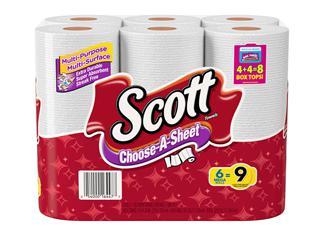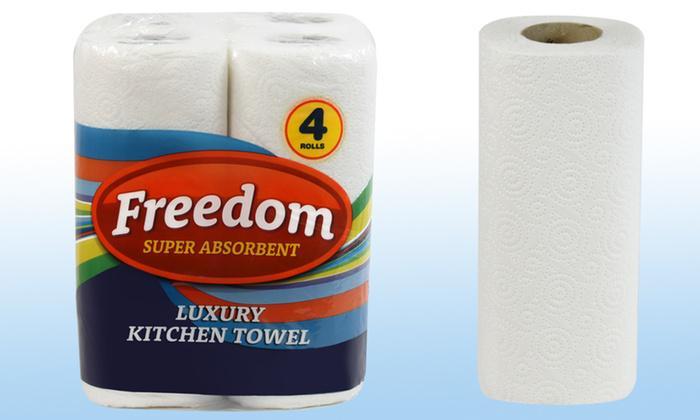The first image is the image on the left, the second image is the image on the right. Given the left and right images, does the statement "Each image shows only a sealed package of paper towels and no package contains more than three rolls." hold true? Answer yes or no. No. The first image is the image on the left, the second image is the image on the right. Assess this claim about the two images: "An image includes some amount of paper towel that is not in its wrapped package.". Correct or not? Answer yes or no. Yes. 